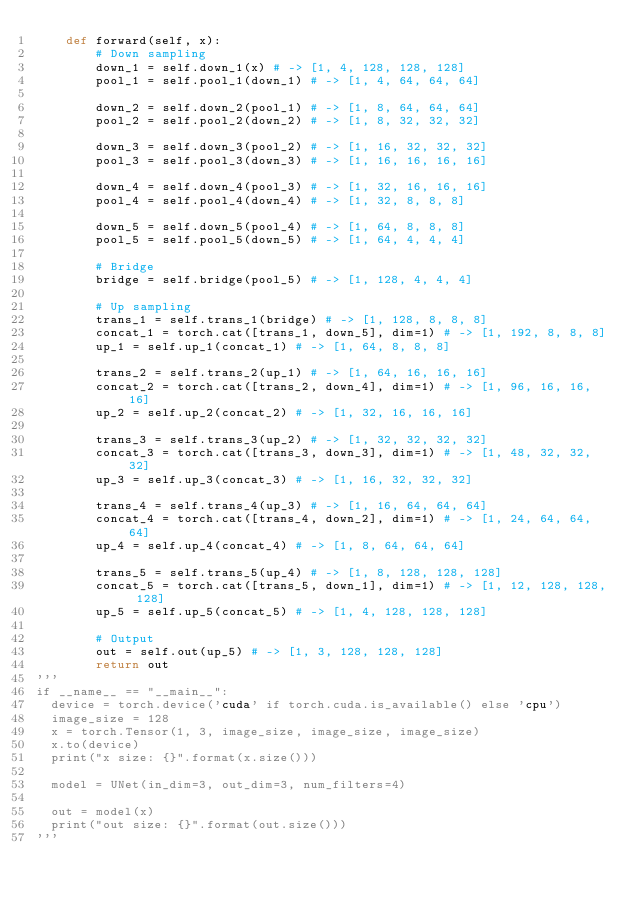<code> <loc_0><loc_0><loc_500><loc_500><_Python_>    def forward(self, x):
        # Down sampling
        down_1 = self.down_1(x) # -> [1, 4, 128, 128, 128]
        pool_1 = self.pool_1(down_1) # -> [1, 4, 64, 64, 64]
        
        down_2 = self.down_2(pool_1) # -> [1, 8, 64, 64, 64]
        pool_2 = self.pool_2(down_2) # -> [1, 8, 32, 32, 32]
        
        down_3 = self.down_3(pool_2) # -> [1, 16, 32, 32, 32]
        pool_3 = self.pool_3(down_3) # -> [1, 16, 16, 16, 16]
        
        down_4 = self.down_4(pool_3) # -> [1, 32, 16, 16, 16]
        pool_4 = self.pool_4(down_4) # -> [1, 32, 8, 8, 8]
        
        down_5 = self.down_5(pool_4) # -> [1, 64, 8, 8, 8]
        pool_5 = self.pool_5(down_5) # -> [1, 64, 4, 4, 4]
        
        # Bridge
        bridge = self.bridge(pool_5) # -> [1, 128, 4, 4, 4]
        
        # Up sampling
        trans_1 = self.trans_1(bridge) # -> [1, 128, 8, 8, 8]
        concat_1 = torch.cat([trans_1, down_5], dim=1) # -> [1, 192, 8, 8, 8]
        up_1 = self.up_1(concat_1) # -> [1, 64, 8, 8, 8]
        
        trans_2 = self.trans_2(up_1) # -> [1, 64, 16, 16, 16]
        concat_2 = torch.cat([trans_2, down_4], dim=1) # -> [1, 96, 16, 16, 16]
        up_2 = self.up_2(concat_2) # -> [1, 32, 16, 16, 16]
        
        trans_3 = self.trans_3(up_2) # -> [1, 32, 32, 32, 32]
        concat_3 = torch.cat([trans_3, down_3], dim=1) # -> [1, 48, 32, 32, 32]
        up_3 = self.up_3(concat_3) # -> [1, 16, 32, 32, 32]
        
        trans_4 = self.trans_4(up_3) # -> [1, 16, 64, 64, 64]
        concat_4 = torch.cat([trans_4, down_2], dim=1) # -> [1, 24, 64, 64, 64]
        up_4 = self.up_4(concat_4) # -> [1, 8, 64, 64, 64]
        
        trans_5 = self.trans_5(up_4) # -> [1, 8, 128, 128, 128]
        concat_5 = torch.cat([trans_5, down_1], dim=1) # -> [1, 12, 128, 128, 128]
        up_5 = self.up_5(concat_5) # -> [1, 4, 128, 128, 128]
        
        # Output
        out = self.out(up_5) # -> [1, 3, 128, 128, 128]
        return out
'''
if __name__ == "__main__":
  device = torch.device('cuda' if torch.cuda.is_available() else 'cpu')
  image_size = 128
  x = torch.Tensor(1, 3, image_size, image_size, image_size)
  x.to(device)
  print("x size: {}".format(x.size()))
  
  model = UNet(in_dim=3, out_dim=3, num_filters=4)
  
  out = model(x)
  print("out size: {}".format(out.size()))
'''
</code> 